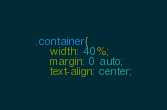<code> <loc_0><loc_0><loc_500><loc_500><_CSS_>.container{
    width: 40%;
    margin: 0 auto;
    text-align: center;</code> 